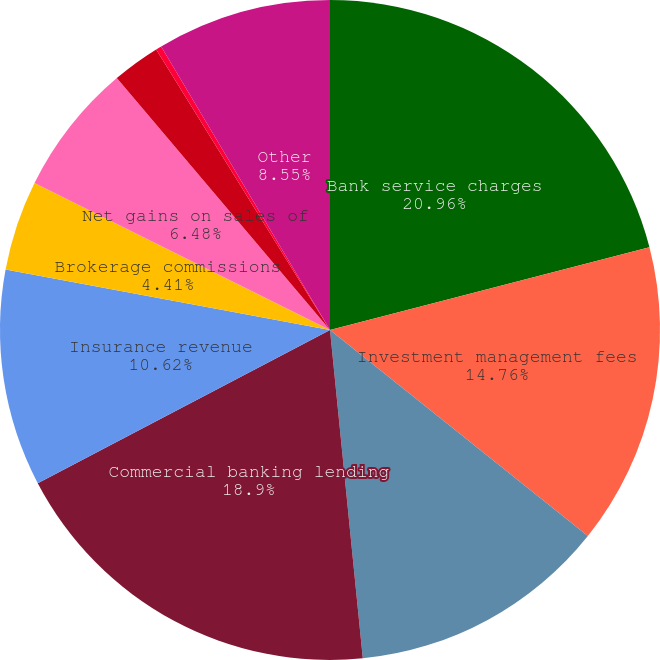Convert chart to OTSL. <chart><loc_0><loc_0><loc_500><loc_500><pie_chart><fcel>Bank service charges<fcel>Investment management fees<fcel>Operating lease income<fcel>Commercial banking lending<fcel>Insurance revenue<fcel>Brokerage commissions<fcel>Net gains on sales of<fcel>Customer interest rate swap<fcel>BOLI<fcel>Other<nl><fcel>20.97%<fcel>14.76%<fcel>12.69%<fcel>18.9%<fcel>10.62%<fcel>4.41%<fcel>6.48%<fcel>2.35%<fcel>0.28%<fcel>8.55%<nl></chart> 